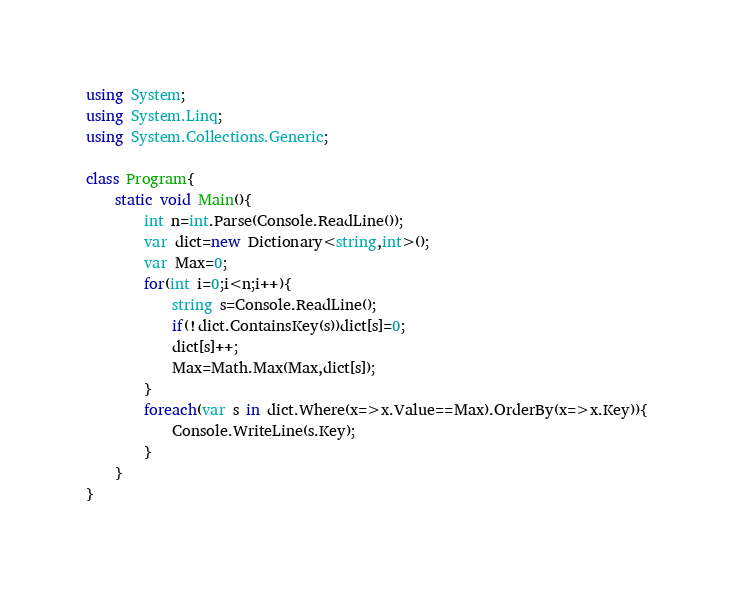Convert code to text. <code><loc_0><loc_0><loc_500><loc_500><_C#_>using System;
using System.Linq;
using System.Collections.Generic;

class Program{
	static void Main(){
		int n=int.Parse(Console.ReadLine());
		var dict=new Dictionary<string,int>();
		var Max=0;
		for(int i=0;i<n;i++){
			string s=Console.ReadLine();
			if(!dict.ContainsKey(s))dict[s]=0;
			dict[s]++;
			Max=Math.Max(Max,dict[s]);
		}
		foreach(var s in dict.Where(x=>x.Value==Max).OrderBy(x=>x.Key)){
			Console.WriteLine(s.Key);
		}
	}
}</code> 